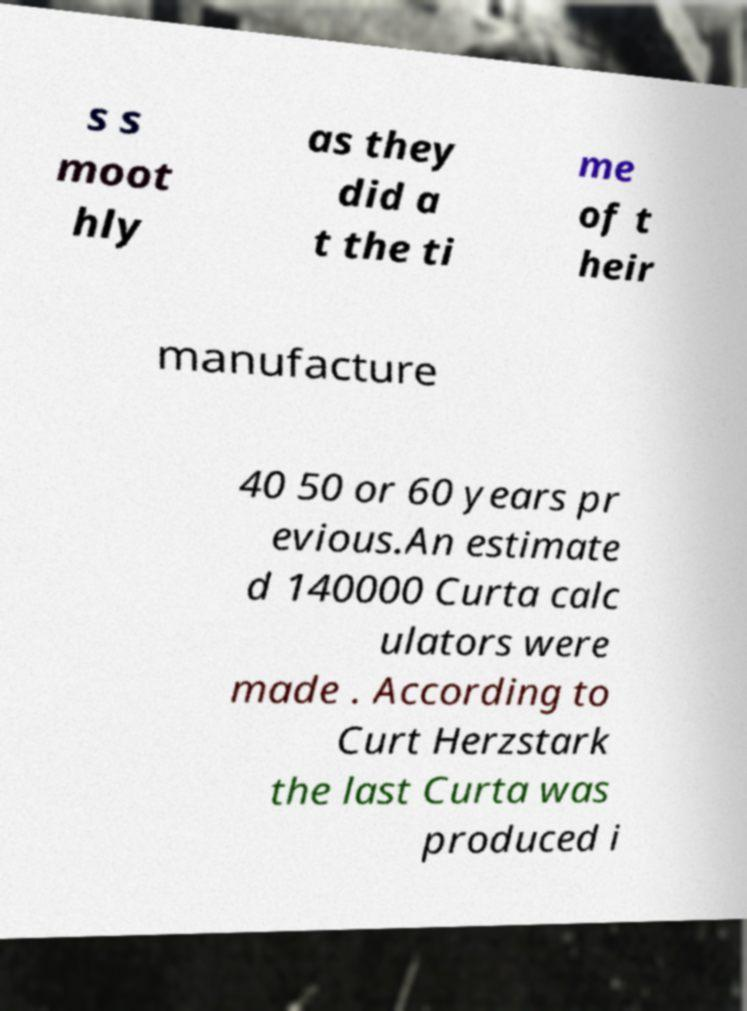I need the written content from this picture converted into text. Can you do that? s s moot hly as they did a t the ti me of t heir manufacture 40 50 or 60 years pr evious.An estimate d 140000 Curta calc ulators were made . According to Curt Herzstark the last Curta was produced i 